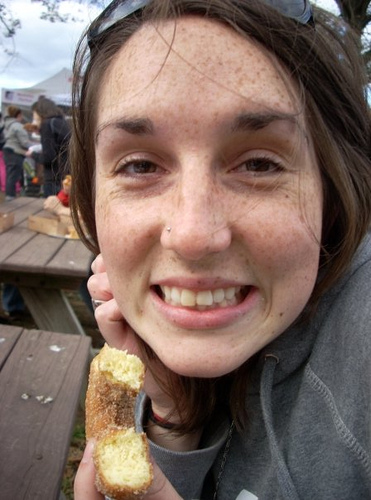What is the person's mood in the picture? The person is smiling and appears to be in a happy and relaxed mood, suggesting they are enjoying the moment, perhaps relishing the food or the experience of the event around them. Why do you think they're enjoying the moment? People usually smile when they are having a good time, so the combination of the pleasant setting, the presence of what seems to be a tasty treat, and the person's relaxed body language all point to them enjoying themselves. 